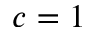<formula> <loc_0><loc_0><loc_500><loc_500>c = 1</formula> 